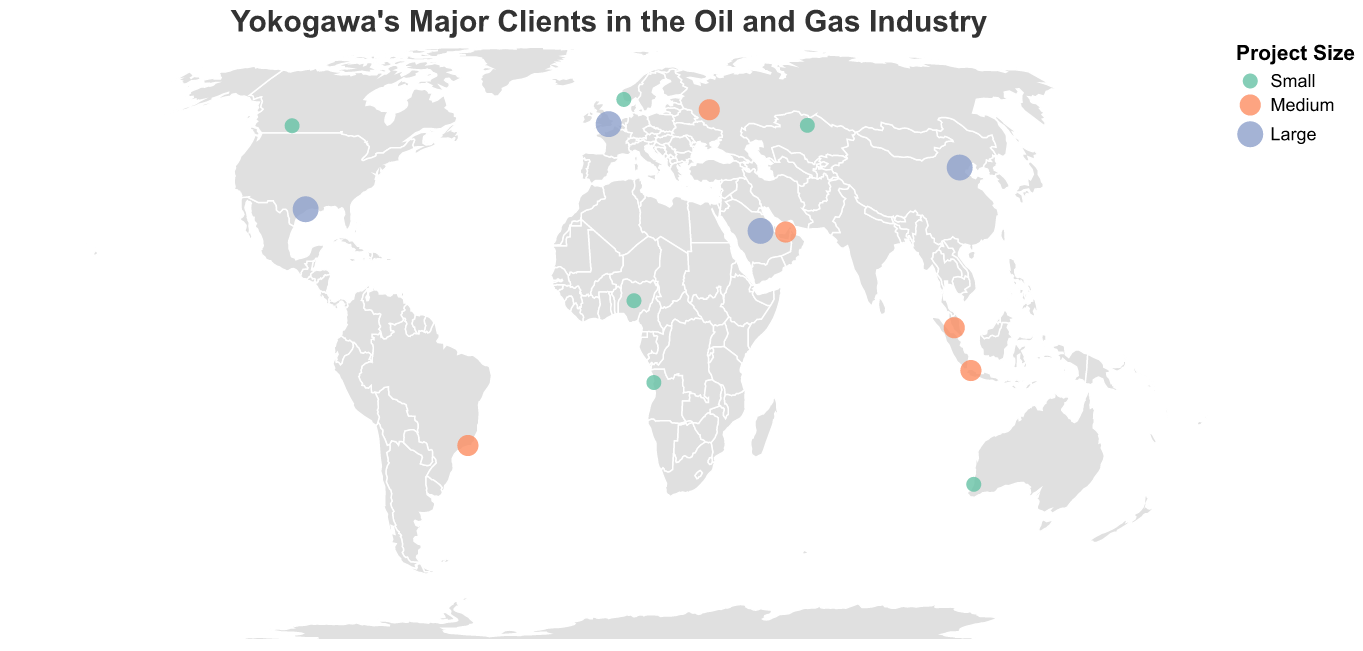Which company has the largest project size in Saudi Arabia? Identify the company located in Saudi Arabia on the map and refer to the tooltip to see the project size.
Answer: Saudi Aramco How many major clients are located in Europe? Look for countries within Europe and count the data points; Russia, United Kingdom, and Norway are considered part of Europe for this context.
Answer: 3 Which countries have medium project sizes? Look at the size and color of the points marked as "medium" in the legend and read the tooltips for country names.
Answer: Russia, Brazil, United Arab Emirates, Malaysia, Indonesia Between China and the United States, which country has a larger project size? Compare the sizes and colors of the circles located in China and the United States. Both have "Large" sizes according to the visualization.
Answer: Both are large Which company in South America has a medium project size? Identify the countries in South America on the map and read the tooltip for companies' project sizes; Brazil is in South America.
Answer: Petrobras How does the distribution of clients with small project sizes compare to those with large project sizes? Observe the colors associated with small and large project sizes on the map and count the data points for each category. Small project sizes are greenish while large project sizes are bluish.
Answer: More clients with small project sizes Which country located in the Middle East has a large project size? Identify countries in the Middle East on the map and check the project sizes listed in the tooltip.
Answer: None What is the range of longitudes covered by clients in the figure? Note the westernmost and easternmost longitudes on the map by looking at the positions of data points.
Answer: From -95.3698 to 116.4074 How many companies in Asia have medium project sizes? Identify countries located in Asia and check the tooltips for project sizes, counting those marked as "medium."
Answer: 2 